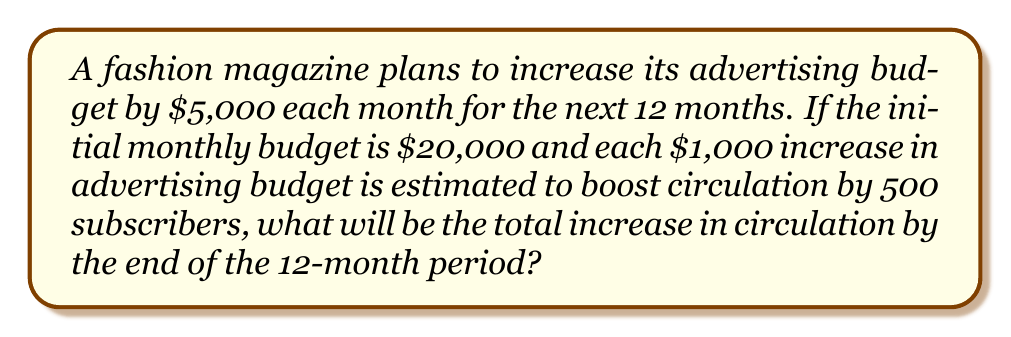Can you answer this question? Let's approach this step-by-step using arithmetic progression:

1) The advertising budget forms an arithmetic sequence with:
   $a_1 = 20,000$ (initial term)
   $d = 5,000$ (common difference)
   $n = 12$ (number of terms)

2) The last term of this sequence is:
   $a_n = a_1 + (n-1)d = 20,000 + (12-1)5,000 = 75,000$

3) The total increase in budget over 12 months is:
   $S_n = \frac{n}{2}(a_1 + a_n) = \frac{12}{2}(20,000 + 75,000) = 570,000$

4) The increase from the initial budget is:
   $570,000 - (12 \times 20,000) = 330,000$

5) Given that each $1,000 increase in budget adds 500 subscribers:
   $\frac{330,000}{1,000} \times 500 = 165,000$

Therefore, the total increase in circulation will be 165,000 subscribers.
Answer: 165,000 subscribers 